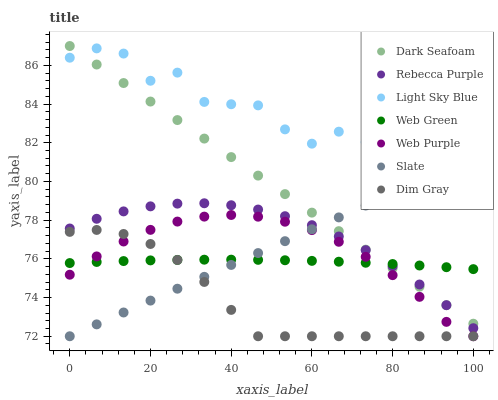Does Dim Gray have the minimum area under the curve?
Answer yes or no. Yes. Does Light Sky Blue have the maximum area under the curve?
Answer yes or no. Yes. Does Slate have the minimum area under the curve?
Answer yes or no. No. Does Slate have the maximum area under the curve?
Answer yes or no. No. Is Dark Seafoam the smoothest?
Answer yes or no. Yes. Is Light Sky Blue the roughest?
Answer yes or no. Yes. Is Slate the smoothest?
Answer yes or no. No. Is Slate the roughest?
Answer yes or no. No. Does Dim Gray have the lowest value?
Answer yes or no. Yes. Does Dark Seafoam have the lowest value?
Answer yes or no. No. Does Dark Seafoam have the highest value?
Answer yes or no. Yes. Does Slate have the highest value?
Answer yes or no. No. Is Dim Gray less than Dark Seafoam?
Answer yes or no. Yes. Is Light Sky Blue greater than Web Purple?
Answer yes or no. Yes. Does Slate intersect Dim Gray?
Answer yes or no. Yes. Is Slate less than Dim Gray?
Answer yes or no. No. Is Slate greater than Dim Gray?
Answer yes or no. No. Does Dim Gray intersect Dark Seafoam?
Answer yes or no. No. 